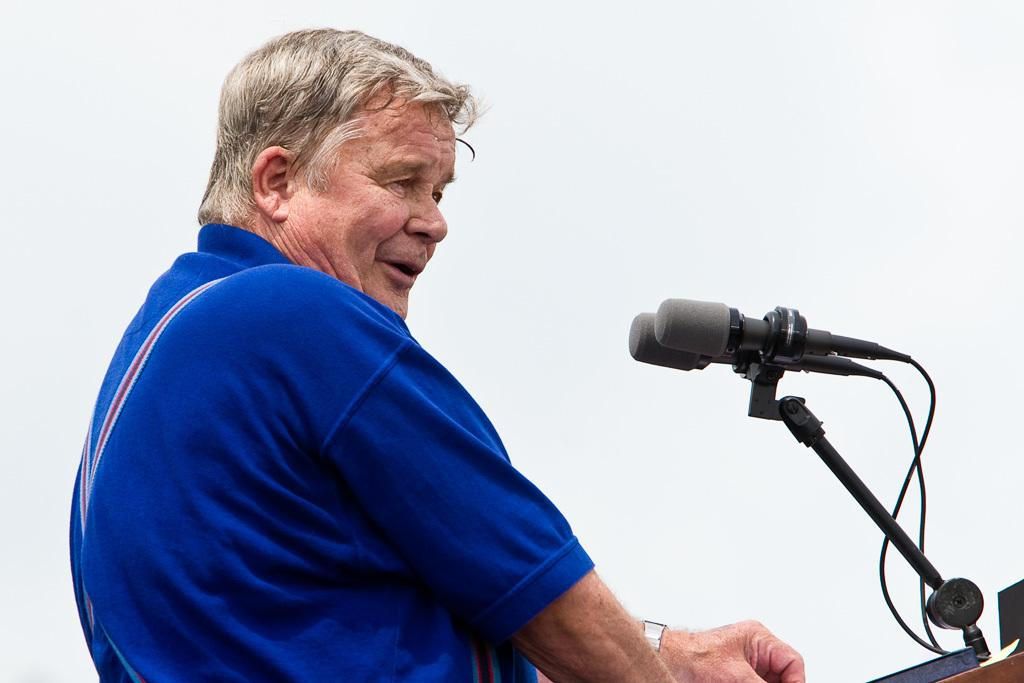Who is the main subject in the image? There is a man in the image. What is the man doing in the image? The man is standing in front of microphones. What type of school can be seen in the background of the image? There is no school visible in the image; it only shows a man standing in front of microphones. 